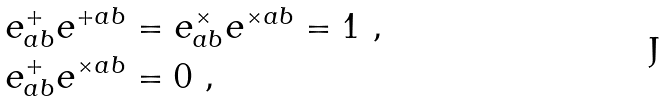Convert formula to latex. <formula><loc_0><loc_0><loc_500><loc_500>& e ^ { + } _ { a b } e ^ { + a b } = e ^ { \times } _ { a b } e ^ { \times a b } = 1 \ , \\ & e ^ { + } _ { a b } e ^ { \times a b } = 0 \ ,</formula> 